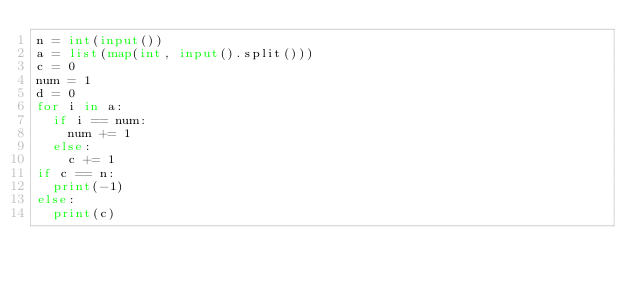<code> <loc_0><loc_0><loc_500><loc_500><_Python_>n = int(input())
a = list(map(int, input().split()))
c = 0
num = 1
d = 0
for i in a:
  if i == num:
    num += 1
  else:
    c += 1
if c == n:
  print(-1)
else:
  print(c)</code> 